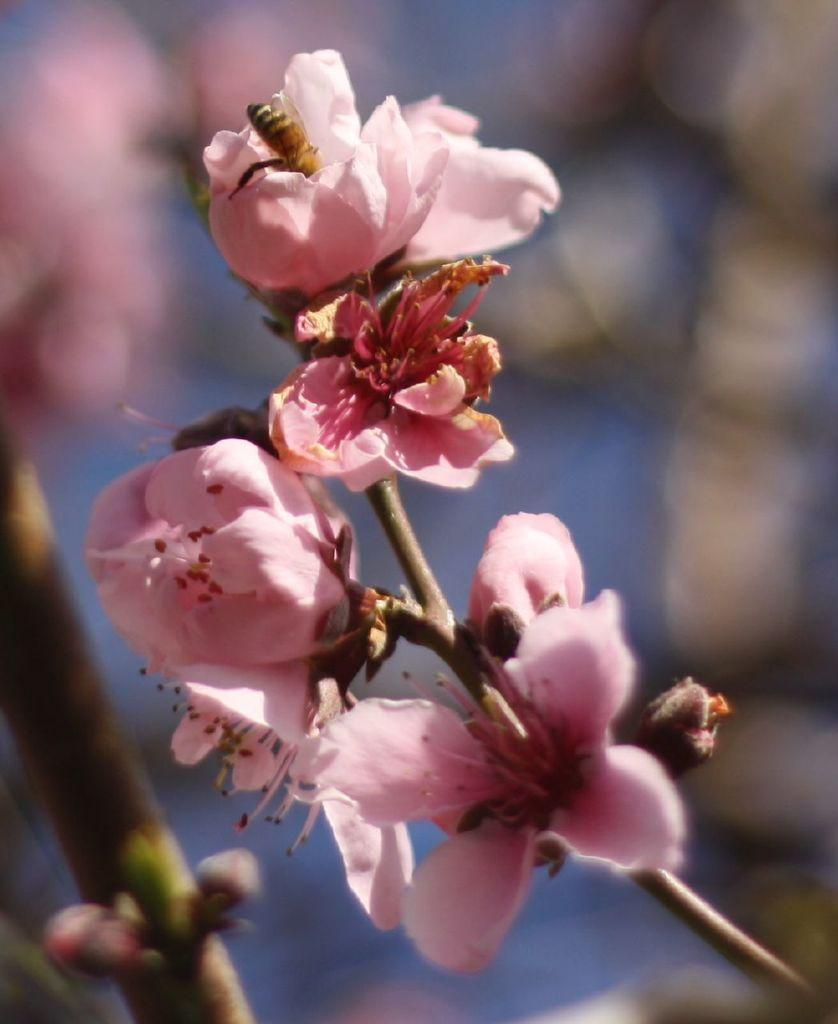What type of living organism can be seen in the image? There is a plant in the image. What specific features can be observed on the plant? There are flowers on the plant. Are there any other living organisms interacting with the plant? Yes, there is an insect on one of the flowers. How would you describe the background of the image? The background of the image is blurred. What type of pear is being held by the hen in the image? There is no pear or hen present in the image; it features a plant with flowers and an insect. How does the rail contribute to the overall composition of the image? There is no rail present in the image; it only contains a plant, flowers, and an insect. 